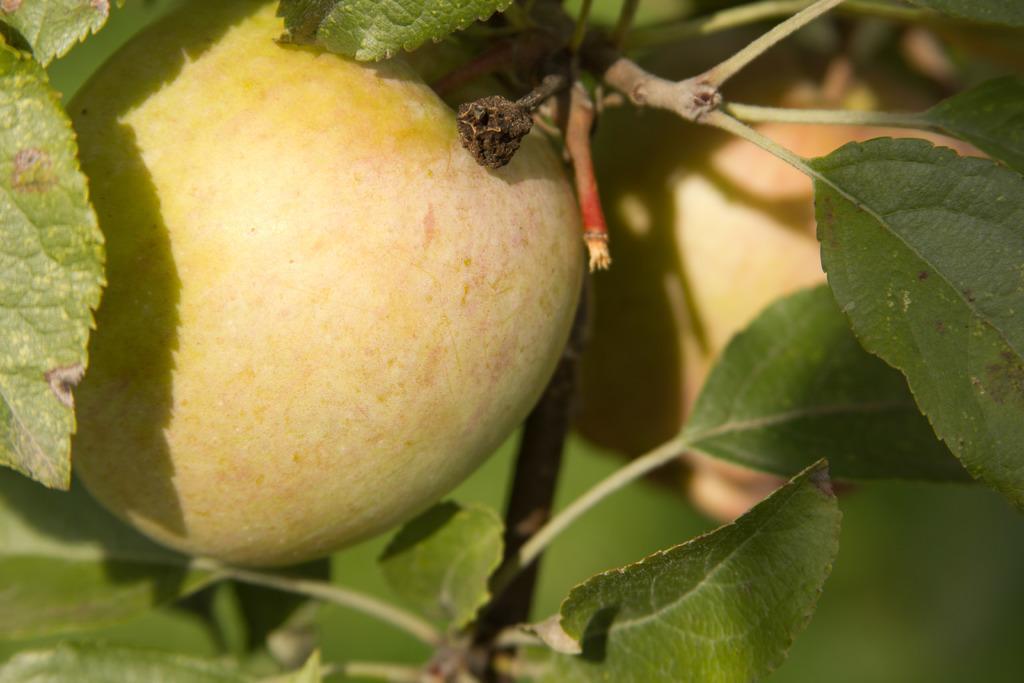Can you describe this image briefly? In this picture we can see fruits and a few green leaves. 